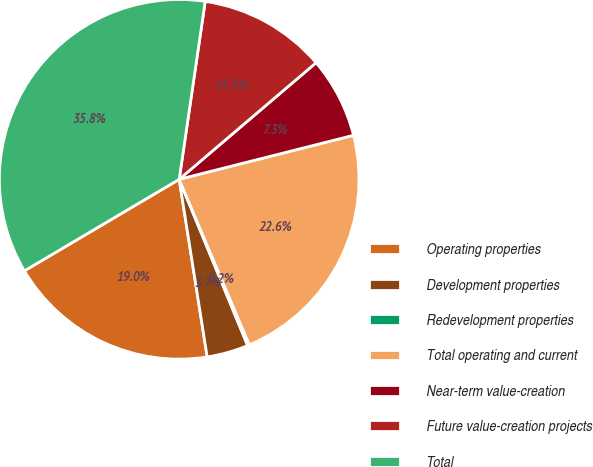Convert chart to OTSL. <chart><loc_0><loc_0><loc_500><loc_500><pie_chart><fcel>Operating properties<fcel>Development properties<fcel>Redevelopment properties<fcel>Total operating and current<fcel>Near-term value-creation<fcel>Future value-creation projects<fcel>Total<nl><fcel>18.99%<fcel>3.73%<fcel>0.16%<fcel>22.56%<fcel>7.29%<fcel>11.46%<fcel>35.81%<nl></chart> 